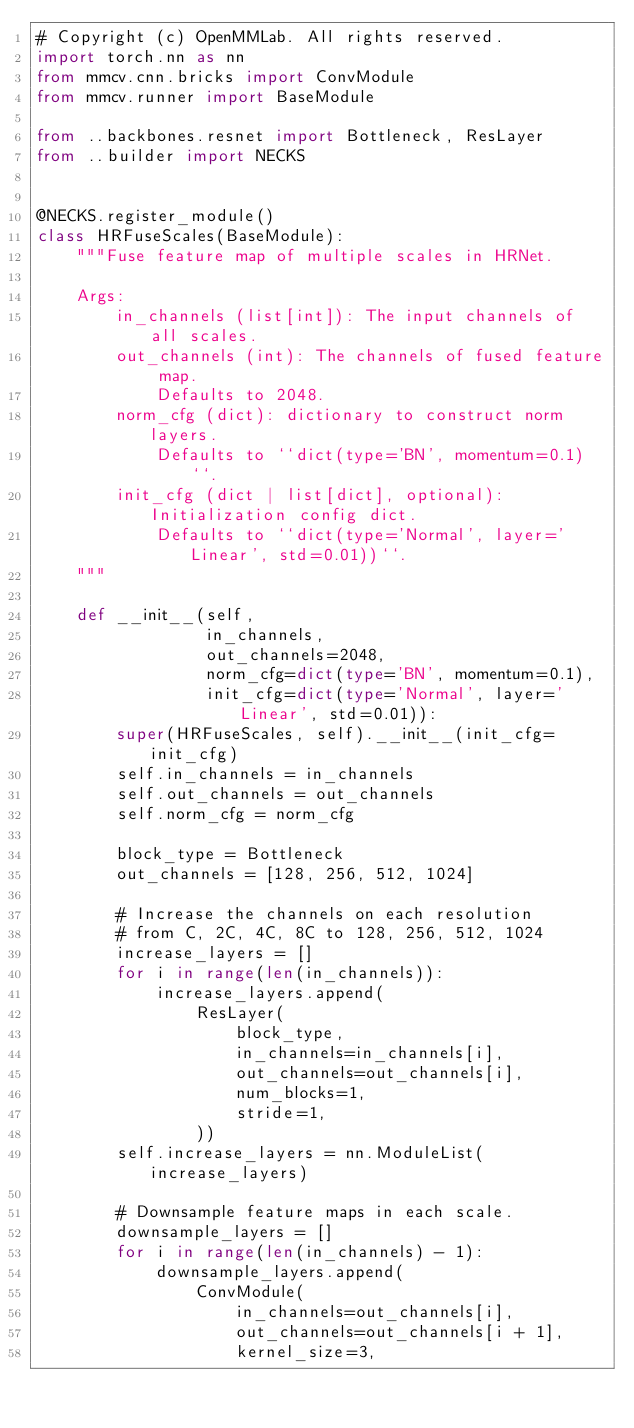Convert code to text. <code><loc_0><loc_0><loc_500><loc_500><_Python_># Copyright (c) OpenMMLab. All rights reserved.
import torch.nn as nn
from mmcv.cnn.bricks import ConvModule
from mmcv.runner import BaseModule

from ..backbones.resnet import Bottleneck, ResLayer
from ..builder import NECKS


@NECKS.register_module()
class HRFuseScales(BaseModule):
    """Fuse feature map of multiple scales in HRNet.

    Args:
        in_channels (list[int]): The input channels of all scales.
        out_channels (int): The channels of fused feature map.
            Defaults to 2048.
        norm_cfg (dict): dictionary to construct norm layers.
            Defaults to ``dict(type='BN', momentum=0.1)``.
        init_cfg (dict | list[dict], optional): Initialization config dict.
            Defaults to ``dict(type='Normal', layer='Linear', std=0.01))``.
    """

    def __init__(self,
                 in_channels,
                 out_channels=2048,
                 norm_cfg=dict(type='BN', momentum=0.1),
                 init_cfg=dict(type='Normal', layer='Linear', std=0.01)):
        super(HRFuseScales, self).__init__(init_cfg=init_cfg)
        self.in_channels = in_channels
        self.out_channels = out_channels
        self.norm_cfg = norm_cfg

        block_type = Bottleneck
        out_channels = [128, 256, 512, 1024]

        # Increase the channels on each resolution
        # from C, 2C, 4C, 8C to 128, 256, 512, 1024
        increase_layers = []
        for i in range(len(in_channels)):
            increase_layers.append(
                ResLayer(
                    block_type,
                    in_channels=in_channels[i],
                    out_channels=out_channels[i],
                    num_blocks=1,
                    stride=1,
                ))
        self.increase_layers = nn.ModuleList(increase_layers)

        # Downsample feature maps in each scale.
        downsample_layers = []
        for i in range(len(in_channels) - 1):
            downsample_layers.append(
                ConvModule(
                    in_channels=out_channels[i],
                    out_channels=out_channels[i + 1],
                    kernel_size=3,</code> 